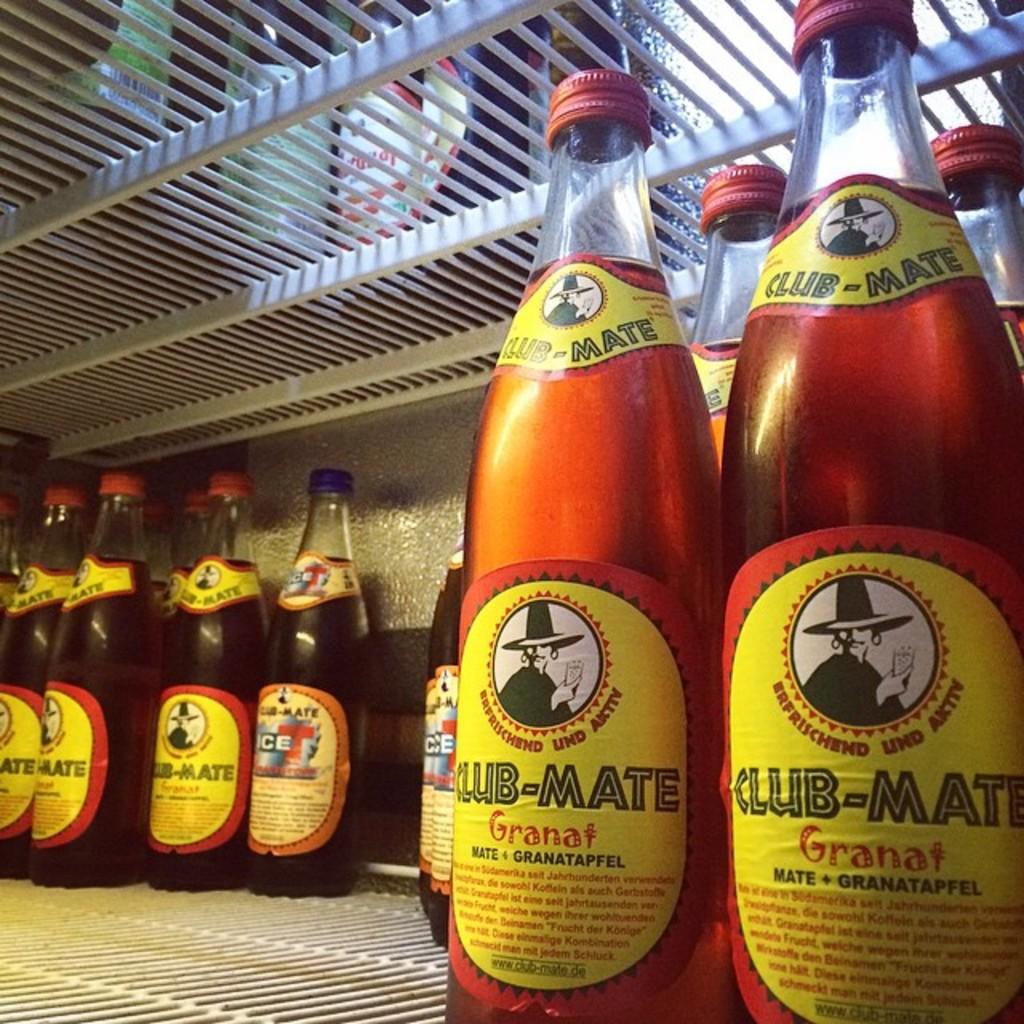What is the name of the beverage on the right?
Make the answer very short. Club-mate. 